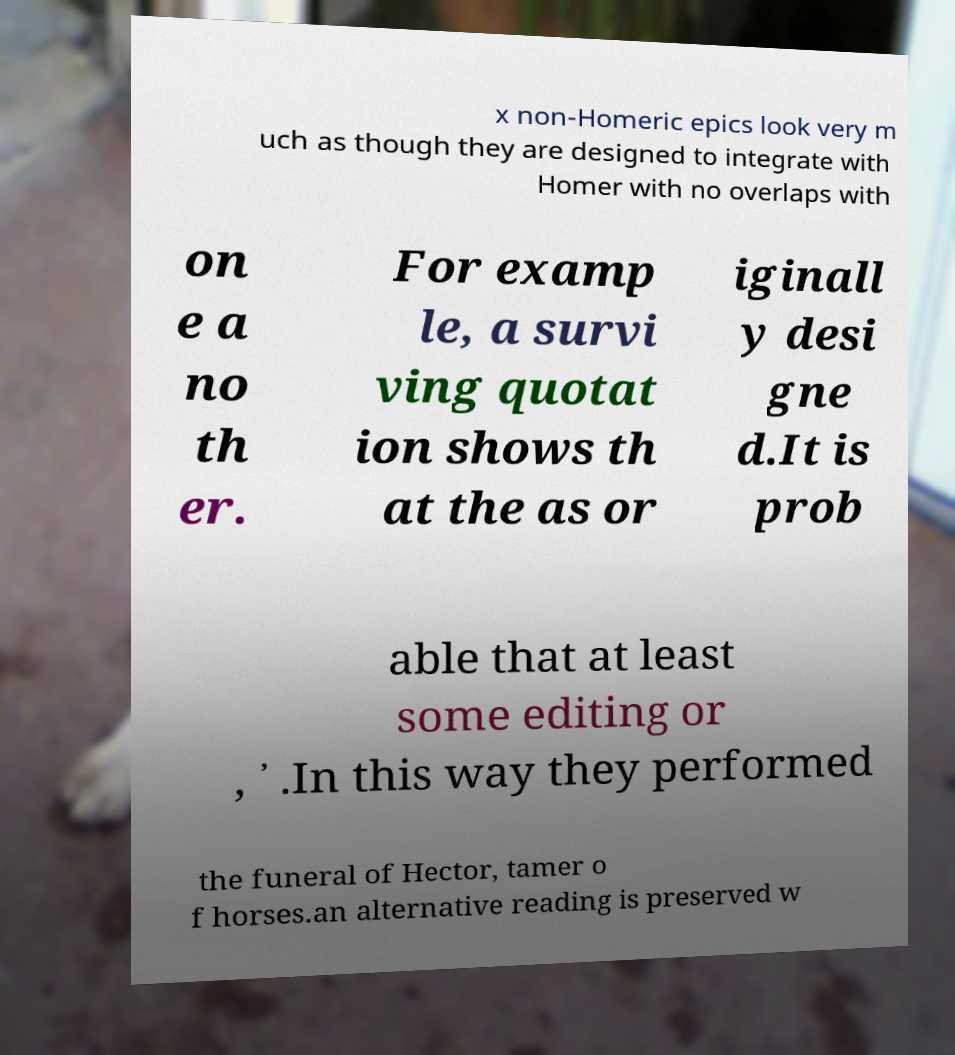Please identify and transcribe the text found in this image. x non-Homeric epics look very m uch as though they are designed to integrate with Homer with no overlaps with on e a no th er. For examp le, a survi ving quotat ion shows th at the as or iginall y desi gne d.It is prob able that at least some editing or , ᾽ .In this way they performed the funeral of Hector, tamer o f horses.an alternative reading is preserved w 